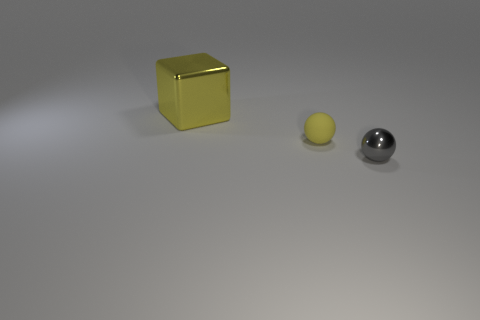Add 3 small yellow objects. How many objects exist? 6 Subtract all cubes. How many objects are left? 2 Subtract 2 spheres. How many spheres are left? 0 Subtract all green spheres. Subtract all green cubes. How many spheres are left? 2 Subtract all gray cylinders. How many brown cubes are left? 0 Subtract all red metallic objects. Subtract all yellow things. How many objects are left? 1 Add 2 spheres. How many spheres are left? 4 Add 2 yellow rubber objects. How many yellow rubber objects exist? 3 Subtract all yellow balls. How many balls are left? 1 Subtract 0 purple cubes. How many objects are left? 3 